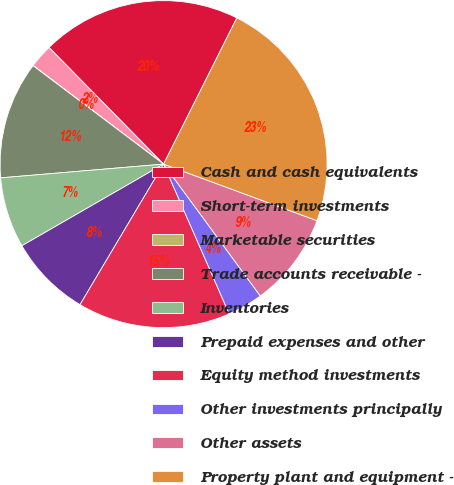Convert chart to OTSL. <chart><loc_0><loc_0><loc_500><loc_500><pie_chart><fcel>Cash and cash equivalents<fcel>Short-term investments<fcel>Marketable securities<fcel>Trade accounts receivable -<fcel>Inventories<fcel>Prepaid expenses and other<fcel>Equity method investments<fcel>Other investments principally<fcel>Other assets<fcel>Property plant and equipment -<nl><fcel>19.75%<fcel>2.34%<fcel>0.02%<fcel>11.62%<fcel>6.98%<fcel>8.14%<fcel>15.11%<fcel>3.5%<fcel>9.3%<fcel>23.23%<nl></chart> 